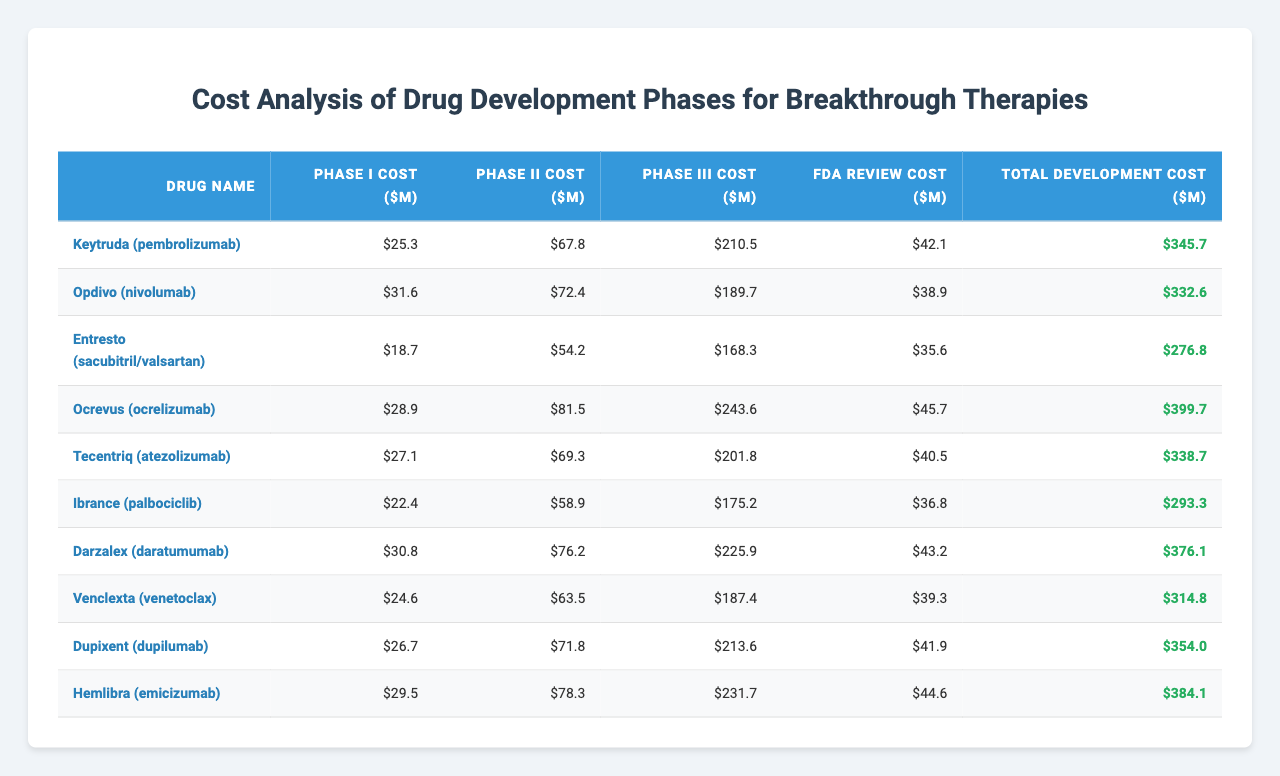What is the highest total development cost in the table? The highest total development cost can be identified by scanning down the "Total Development Cost ($M)" column. The highest value is 399.7, attributed to Ocrevus (ocrelizumab).
Answer: 399.7 Which drug has the lowest Phase I cost? By examining the "Phase I Cost ($M)" column, the lowest value is 18.7, which corresponds to Entresto (sacubitril/valsartan).
Answer: 18.7 What is the total development cost for Opdivo (nivolumab) and Dupixent (dupilumab)? The total development cost for Opdivo is 332.6 and for Dupixent is 354.0. Adding these values (332.6 + 354.0) gives 686.6.
Answer: 686.6 Is the total development cost for Keytruda (pembrolizumab) greater than 300 million? Keytruda's total development cost is 345.7 million, which is greater than 300 million.
Answer: Yes How much does Phase III cost for the drug with the second-highest total development cost? The drug with the second-highest total development cost is Darzalex (daratumumab) with a total cost of 376.1 million. The Phase III cost for Darzalex is 225.9 million.
Answer: 225.9 What is the average Phase II cost across all drugs listed? To find the average Phase II cost, sum the values of the "Phase II Cost ($M)" column (67.8 + 72.4 + 54.2 + 81.5 + 69.3 + 58.9 + 76.2 + 63.5 + 71.8 + 78.3 =  570.9) and divide by the number of drugs (10). So, 570.9 / 10 = 57.09.
Answer: 57.09 Which drug has the highest cost in the FDA review phase? Looking at the "FDA Review Cost ($M)" column, the highest value is 45.7 for Ocrevus (ocrelizumab).
Answer: Ocrevus What is the difference between the total development costs of Hemlibra (emicizumab) and Ibrance (palbociclib)? The total development cost for Hemlibra is 384.1 million and for Ibrance it is 293.3 million. The difference is 384.1 - 293.3 = 90.8 million.
Answer: 90.8 How much more does Ocrevus cost in Phase III compared to Entresto? Ocrevus has a Phase III cost of 243.6 million, while Entresto has a Phase III cost of 168.3 million. The difference is 243.6 - 168.3 = 75.3 million.
Answer: 75.3 What portion of the total development cost for Tecentriq is accounted for by the FDA review cost? The total development cost for Tecentriq is 338.7 million and the FDA review cost is 40.5 million. The portion is 40.5 / 338.7 ≈ 0.119 or 11.9%.
Answer: 11.9% 